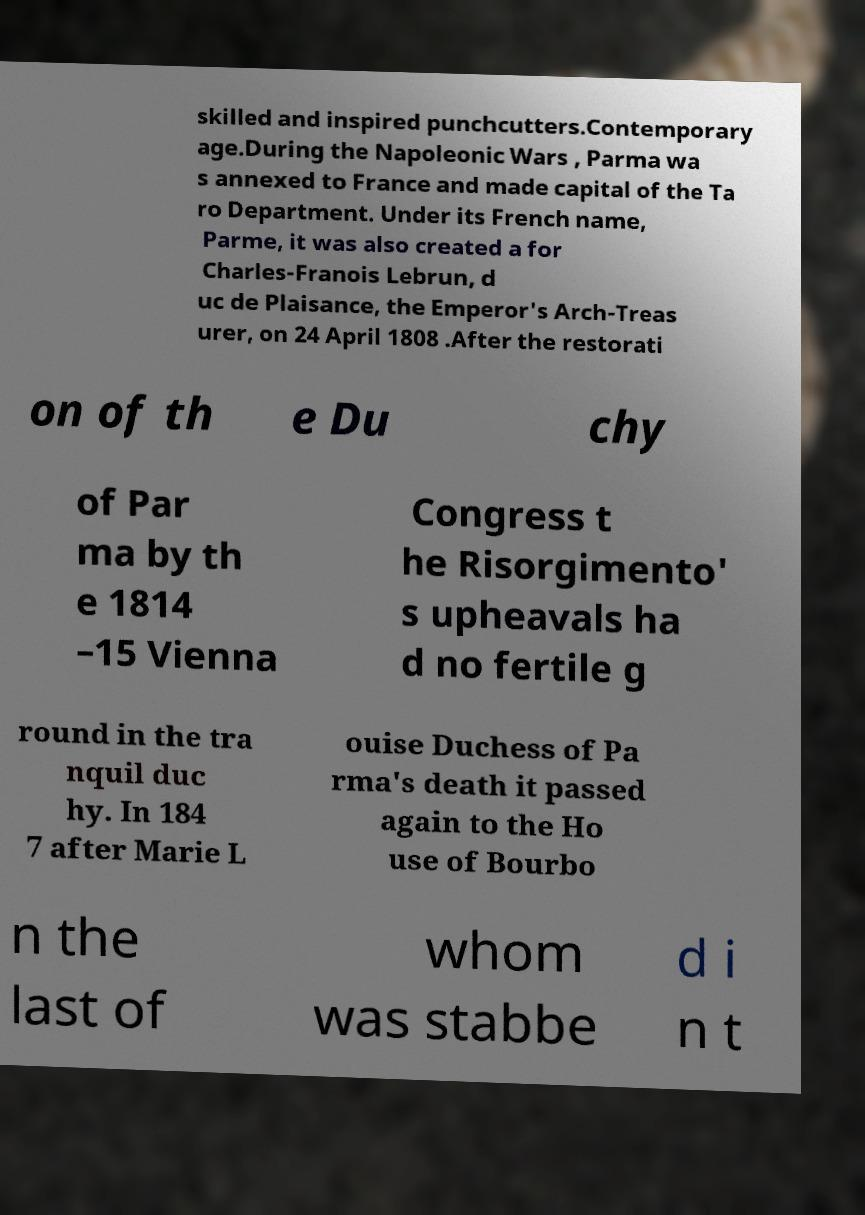Please identify and transcribe the text found in this image. skilled and inspired punchcutters.Contemporary age.During the Napoleonic Wars , Parma wa s annexed to France and made capital of the Ta ro Department. Under its French name, Parme, it was also created a for Charles-Franois Lebrun, d uc de Plaisance, the Emperor's Arch-Treas urer, on 24 April 1808 .After the restorati on of th e Du chy of Par ma by th e 1814 –15 Vienna Congress t he Risorgimento' s upheavals ha d no fertile g round in the tra nquil duc hy. In 184 7 after Marie L ouise Duchess of Pa rma's death it passed again to the Ho use of Bourbo n the last of whom was stabbe d i n t 